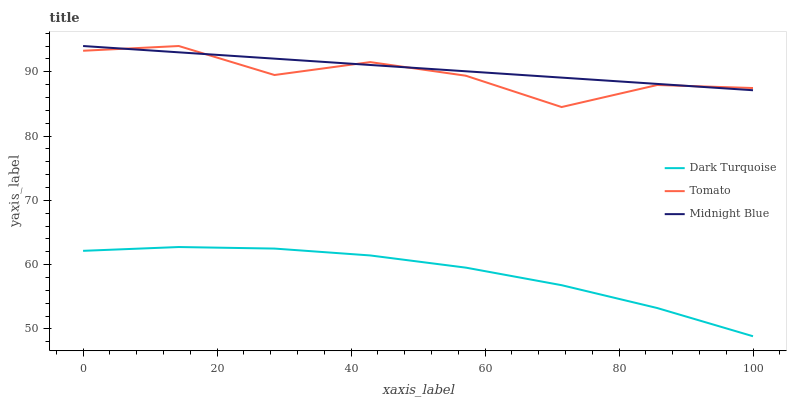Does Dark Turquoise have the minimum area under the curve?
Answer yes or no. Yes. Does Midnight Blue have the maximum area under the curve?
Answer yes or no. Yes. Does Midnight Blue have the minimum area under the curve?
Answer yes or no. No. Does Dark Turquoise have the maximum area under the curve?
Answer yes or no. No. Is Midnight Blue the smoothest?
Answer yes or no. Yes. Is Tomato the roughest?
Answer yes or no. Yes. Is Dark Turquoise the smoothest?
Answer yes or no. No. Is Dark Turquoise the roughest?
Answer yes or no. No. Does Dark Turquoise have the lowest value?
Answer yes or no. Yes. Does Midnight Blue have the lowest value?
Answer yes or no. No. Does Midnight Blue have the highest value?
Answer yes or no. Yes. Does Dark Turquoise have the highest value?
Answer yes or no. No. Is Dark Turquoise less than Midnight Blue?
Answer yes or no. Yes. Is Tomato greater than Dark Turquoise?
Answer yes or no. Yes. Does Tomato intersect Midnight Blue?
Answer yes or no. Yes. Is Tomato less than Midnight Blue?
Answer yes or no. No. Is Tomato greater than Midnight Blue?
Answer yes or no. No. Does Dark Turquoise intersect Midnight Blue?
Answer yes or no. No. 